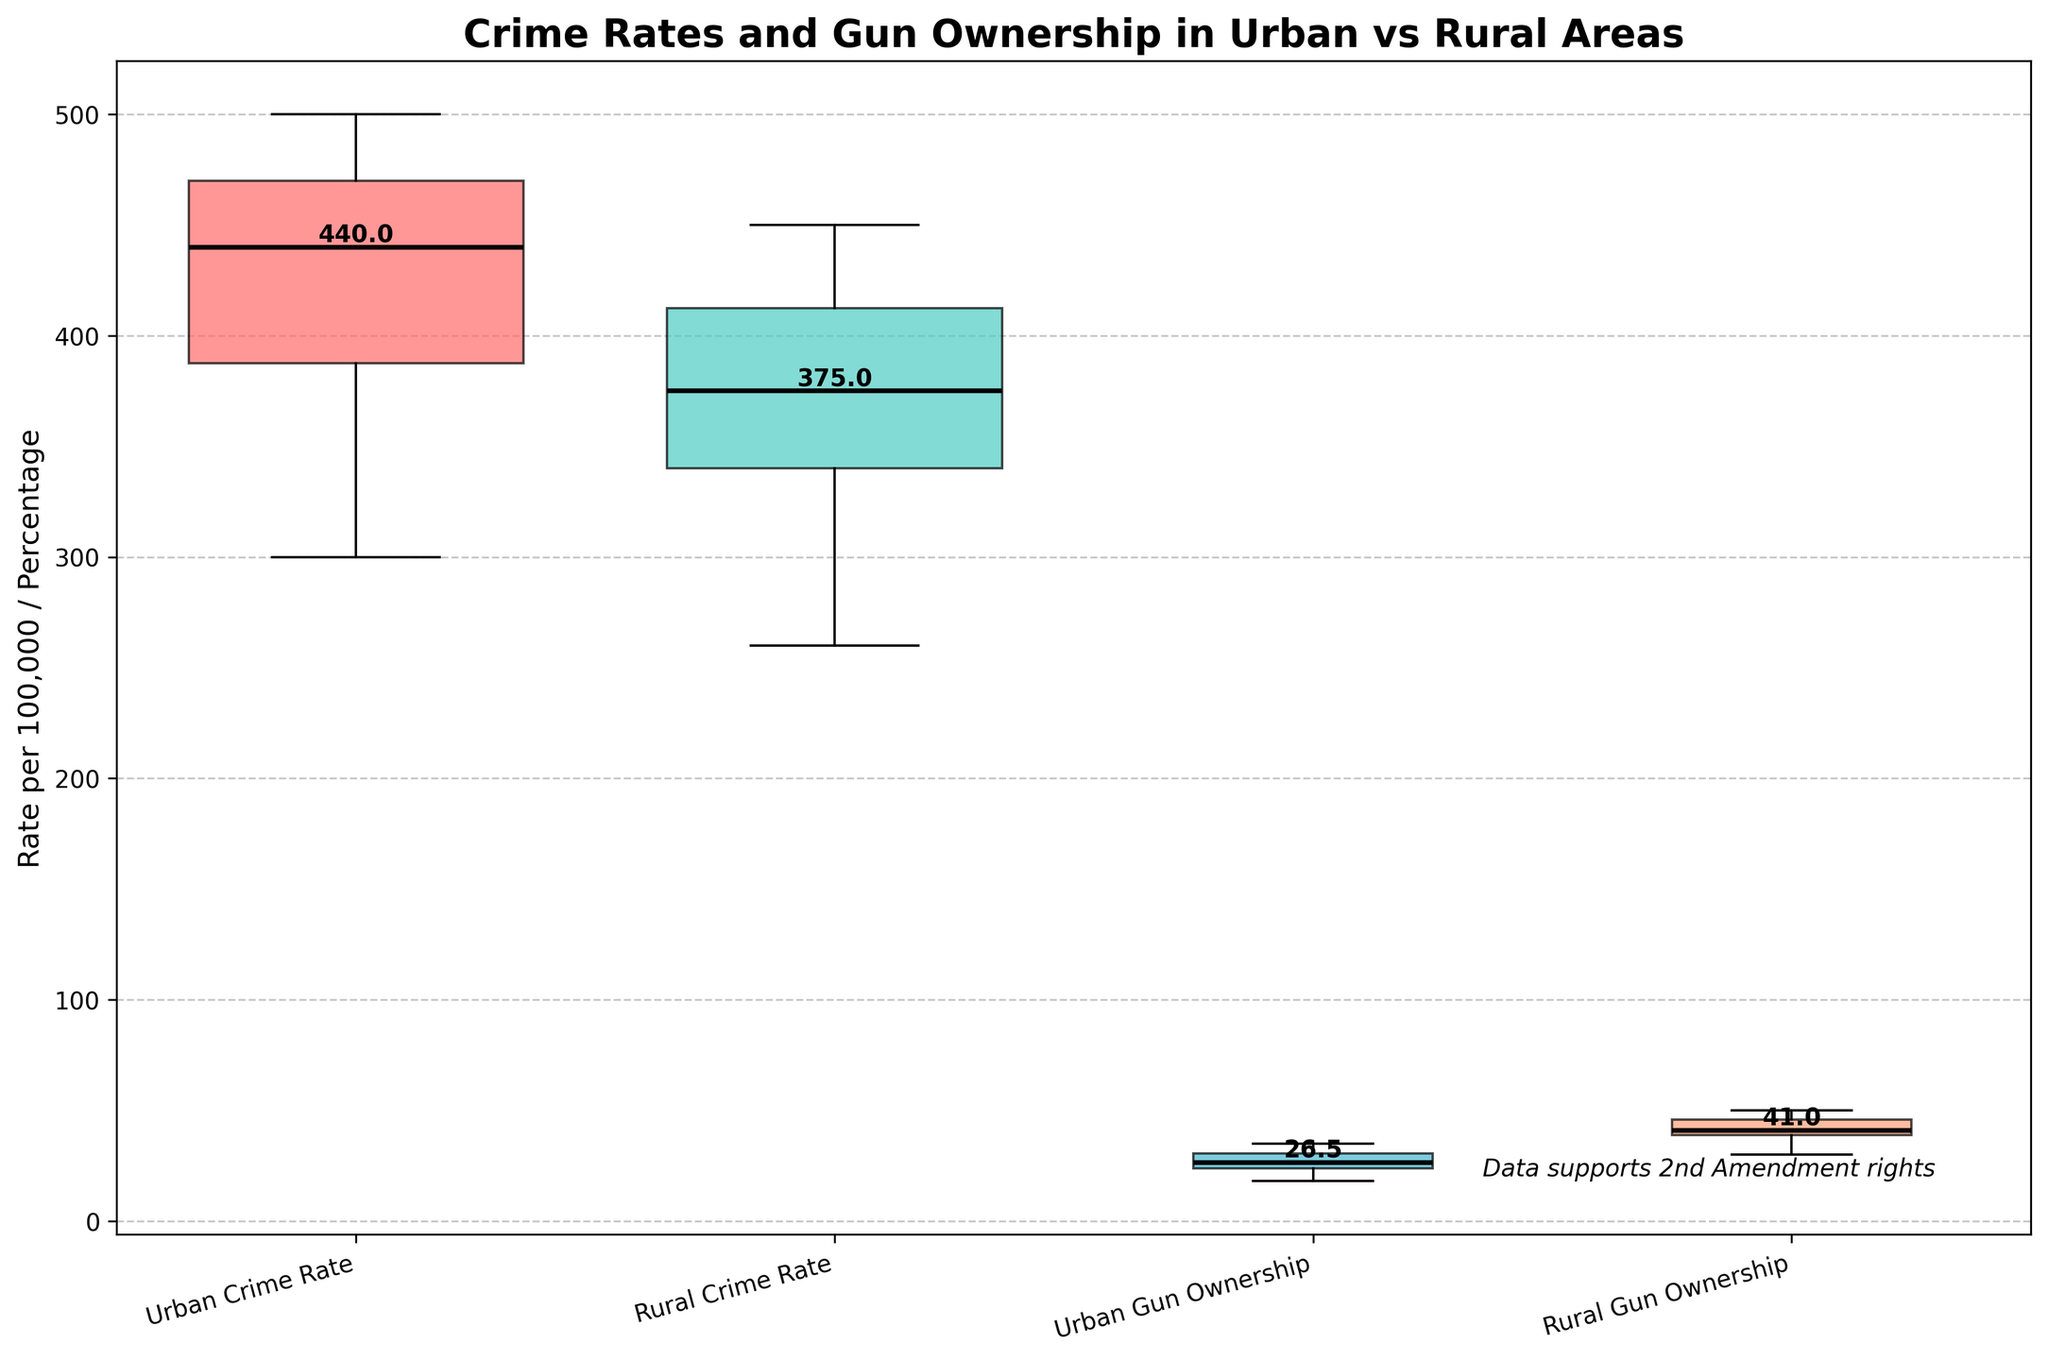In what type of area does the crime rate seem higher? The boxplot shows comparisons between urban and rural crime rates. The urban crime rate boxplot has generally higher values and an overall wider spread. This indicates that urban areas have higher crime rates compared to rural areas.
Answer: Urban areas What's the median crime rate in rural areas? To find the median, look at the central horizontal line in the "Rural Crime Rate" boxplot. It is approximately at 380 per 100,000.
Answer: 380 per 100,000 Which group has the highest median gun ownership percentage? Compare the medians of "Urban Gun Ownership" and "Rural Gun Ownership". The median for rural areas is higher, around 40%, compared to the median for urban areas, around 30%.
Answer: Rural areas What is indicated by the width differences between the boxplots? The different widths indicate that rural areas have more data points for both crime rates and gun ownership percentages compared to urban areas. Urban area boxplots are narrower.
Answer: Rural areas have more data points Is higher gun ownership associated with higher crime rates in rural areas? Comparing the rural gun ownership percentage and crime rates boxplots, one can see that both have higher median values, but this doesn't necessarily imply causation, only correlation.
Answer: No direct causation indicated How does the median urban crime rate compare to the median rural crime rate? The median urban crime rate appears to be higher than the rural crime rate based on their respective boxplots.
Answer: Urban crime rate is higher Are urban or rural gun ownership percentages more spread out? The spread of data in a boxplot is indicated by the length of the box and whiskers. The "Urban Gun Ownership" percentage has a more compact interquartile range and shorter whiskers compared to "Rural Gun Ownership," which has a wider spread.
Answer: Rural gun ownership percentages What can be inferred from the medians of the urban and rural gun ownership percentages? The medians show that rural areas have a higher gun ownership percentage, approximately 40%, compared to urban areas at about 30%.
Answer: Rural areas have higher medians Which category has the lowest median value in the entire plot? By comparing the medians across all categories, "Urban Gun Ownership" has the lowest median, which is around 25%.
Answer: "Urban Gun Ownership" How do urban crime rates and rural gun ownership percentages compare? Urban crime rates have medians around 400 to 500 per 100,000, and rural gun ownership percentages are around 40-50%. This comparison shows no direct relationship but highlights urban crime rates might be unrelated to rural gun ownership.
Answer: No direct relationship shown Is there a notable difference between urban and rural crime rates in the plot? The notable differences are seen since urban crime rates are higher and present a broader range, whereas rural crime rates are lower and less variable.
Answer: Yes 